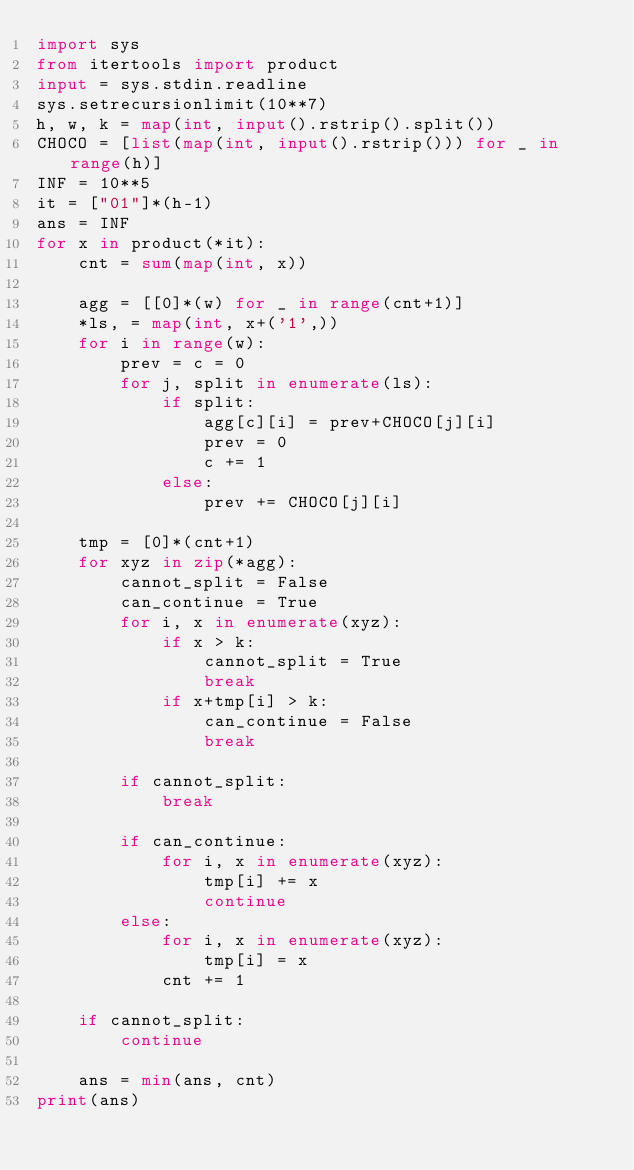Convert code to text. <code><loc_0><loc_0><loc_500><loc_500><_Python_>import sys
from itertools import product
input = sys.stdin.readline
sys.setrecursionlimit(10**7)
h, w, k = map(int, input().rstrip().split())
CHOCO = [list(map(int, input().rstrip())) for _ in range(h)]
INF = 10**5
it = ["01"]*(h-1)
ans = INF
for x in product(*it):
    cnt = sum(map(int, x))

    agg = [[0]*(w) for _ in range(cnt+1)]
    *ls, = map(int, x+('1',))
    for i in range(w):
        prev = c = 0
        for j, split in enumerate(ls):
            if split:
                agg[c][i] = prev+CHOCO[j][i]
                prev = 0
                c += 1
            else:
                prev += CHOCO[j][i]

    tmp = [0]*(cnt+1)
    for xyz in zip(*agg):
        cannot_split = False
        can_continue = True
        for i, x in enumerate(xyz):
            if x > k:
                cannot_split = True
                break
            if x+tmp[i] > k:
                can_continue = False
                break

        if cannot_split:
            break

        if can_continue:
            for i, x in enumerate(xyz):
                tmp[i] += x
                continue
        else:
            for i, x in enumerate(xyz):
                tmp[i] = x
            cnt += 1

    if cannot_split:
        continue

    ans = min(ans, cnt)
print(ans)
</code> 